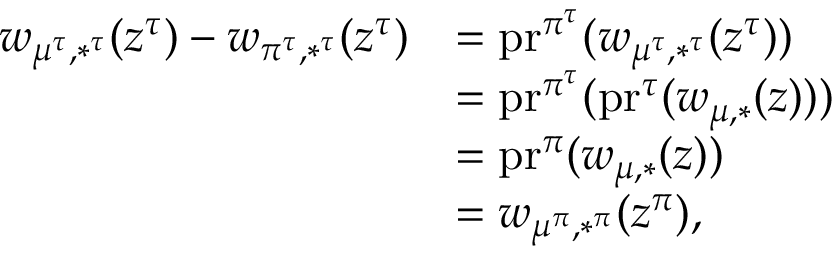<formula> <loc_0><loc_0><loc_500><loc_500>\begin{array} { r l } { w _ { \mu ^ { \tau } , * ^ { \tau } } ( z ^ { \tau } ) - w _ { \pi ^ { \tau } , * ^ { \tau } } ( z ^ { \tau } ) } & { = p r ^ { \pi ^ { \tau } } ( w _ { \mu ^ { \tau } , * ^ { \tau } } ( z ^ { \tau } ) ) } \\ & { = p r ^ { \pi ^ { \tau } } ( p r ^ { \tau } ( w _ { \mu , * } ( z ) ) ) } \\ & { = p r ^ { \pi } ( w _ { \mu , * } ( z ) ) } \\ & { = w _ { \mu ^ { \pi } , * ^ { \pi } } ( z ^ { \pi } ) , } \end{array}</formula> 